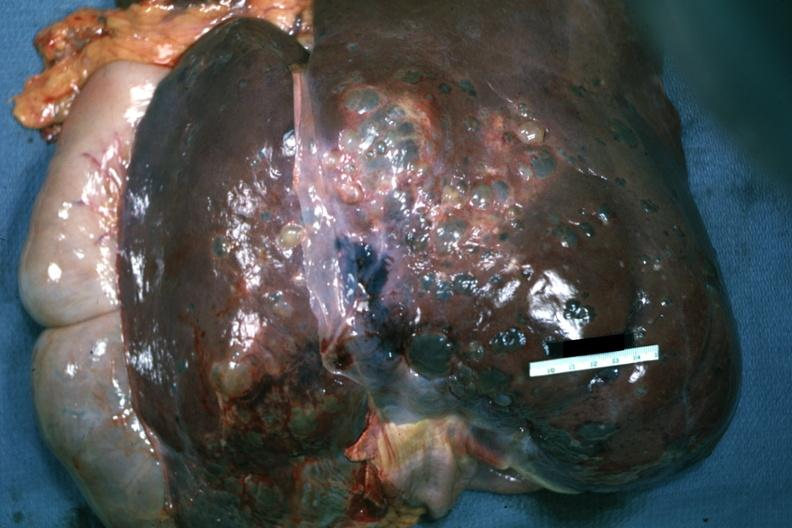what is present?
Answer the question using a single word or phrase. Hepatobiliary 